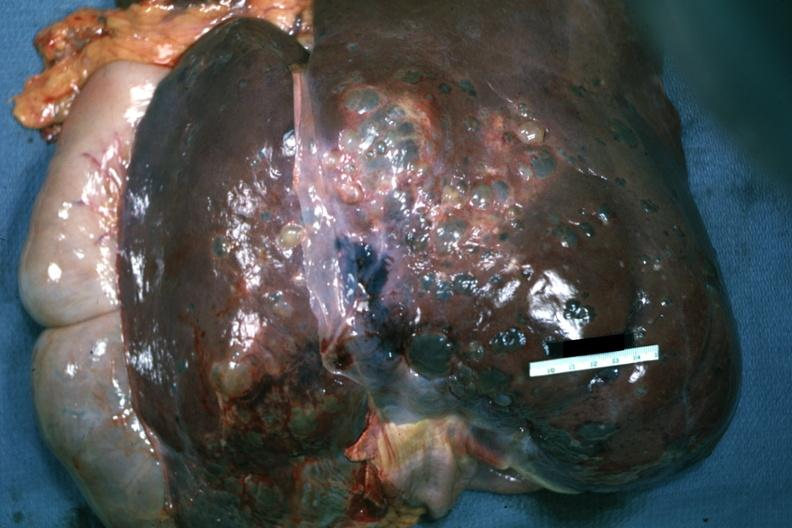what is present?
Answer the question using a single word or phrase. Hepatobiliary 